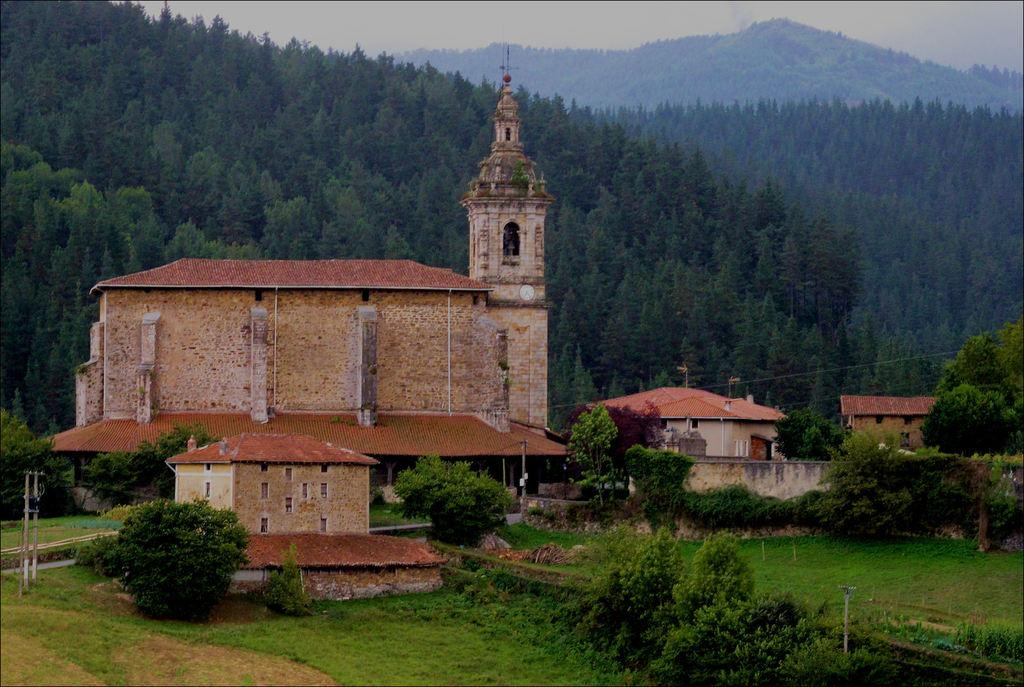What type of natural environment is visible in the foreground of the image? There is grass and trees in the foreground of the image. What type of man-made structures can be seen in the image? There are buildings in the middle of the image. What type of vegetation is visible at the top of the image? There are trees visible at the top of the image. What is visible in the background of the image? The sky is visible at the top of the image. Can you tell me how many quince are hanging from the trees in the image? There is no mention of quince in the image, so it is not possible to determine how many there are. Is there a judge presiding over a trial in the image? There is no indication of a judge or a trial in the image. 